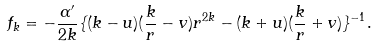Convert formula to latex. <formula><loc_0><loc_0><loc_500><loc_500>f _ { k } = - \frac { \alpha ^ { \prime } } { 2 k } \{ ( k - u ) ( \frac { k } { r } - v ) r ^ { 2 k } - ( k + u ) ( \frac { k } { r } + v ) \} ^ { - 1 } .</formula> 